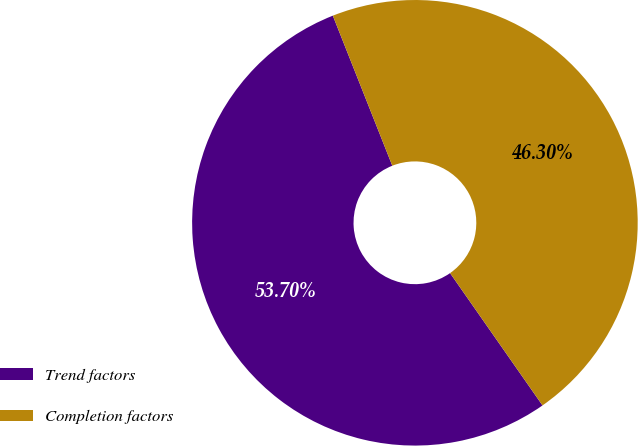Convert chart to OTSL. <chart><loc_0><loc_0><loc_500><loc_500><pie_chart><fcel>Trend factors<fcel>Completion factors<nl><fcel>53.7%<fcel>46.3%<nl></chart> 